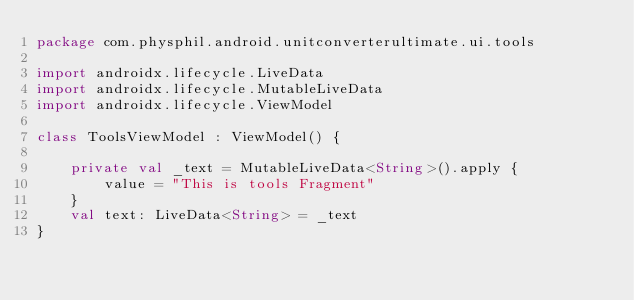<code> <loc_0><loc_0><loc_500><loc_500><_Kotlin_>package com.physphil.android.unitconverterultimate.ui.tools

import androidx.lifecycle.LiveData
import androidx.lifecycle.MutableLiveData
import androidx.lifecycle.ViewModel

class ToolsViewModel : ViewModel() {

    private val _text = MutableLiveData<String>().apply {
        value = "This is tools Fragment"
    }
    val text: LiveData<String> = _text
}</code> 